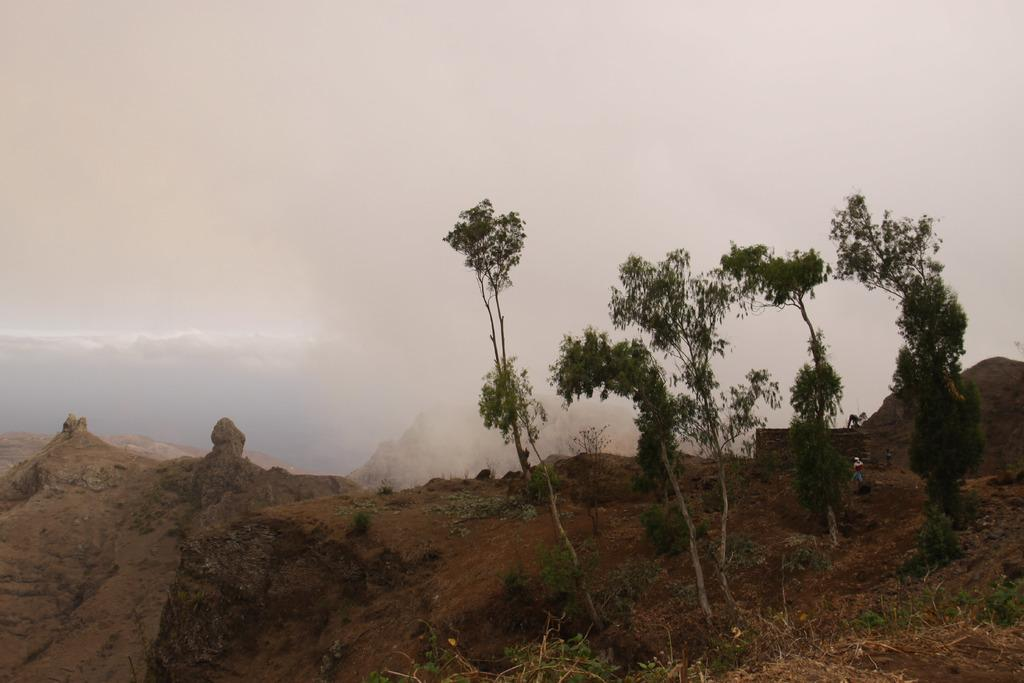What type of area is depicted in the image? There is an open space in the image. What can be found in the open space? There are plants and trees in the open space. What is visible in the background of the image? There are clouds visible in the background of the image. Can you see a hand holding a flame in the image? No, there is no hand or flame present in the image. 